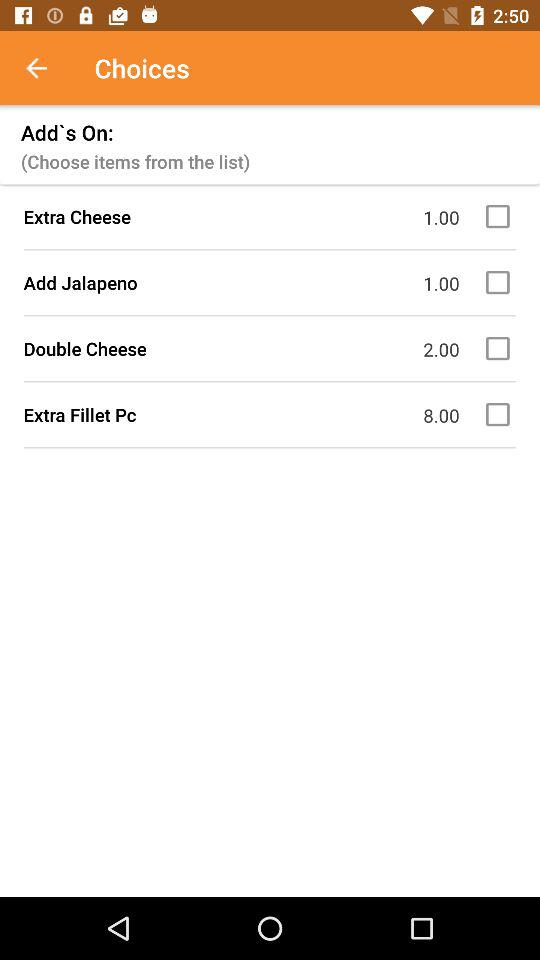How many add-on items are available?
Answer the question using a single word or phrase. 4 